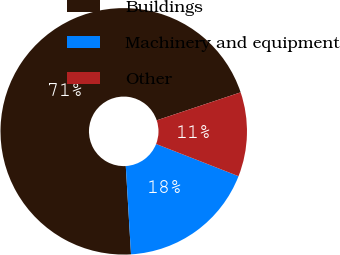Convert chart to OTSL. <chart><loc_0><loc_0><loc_500><loc_500><pie_chart><fcel>Buildings<fcel>Machinery and equipment<fcel>Other<nl><fcel>70.81%<fcel>18.13%<fcel>11.05%<nl></chart> 